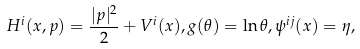Convert formula to latex. <formula><loc_0><loc_0><loc_500><loc_500>H ^ { i } ( x , p ) = \frac { | p | ^ { 2 } } { 2 } + V ^ { i } ( x ) , g ( \theta ) = \ln \theta , \psi ^ { i j } ( x ) = \eta ,</formula> 